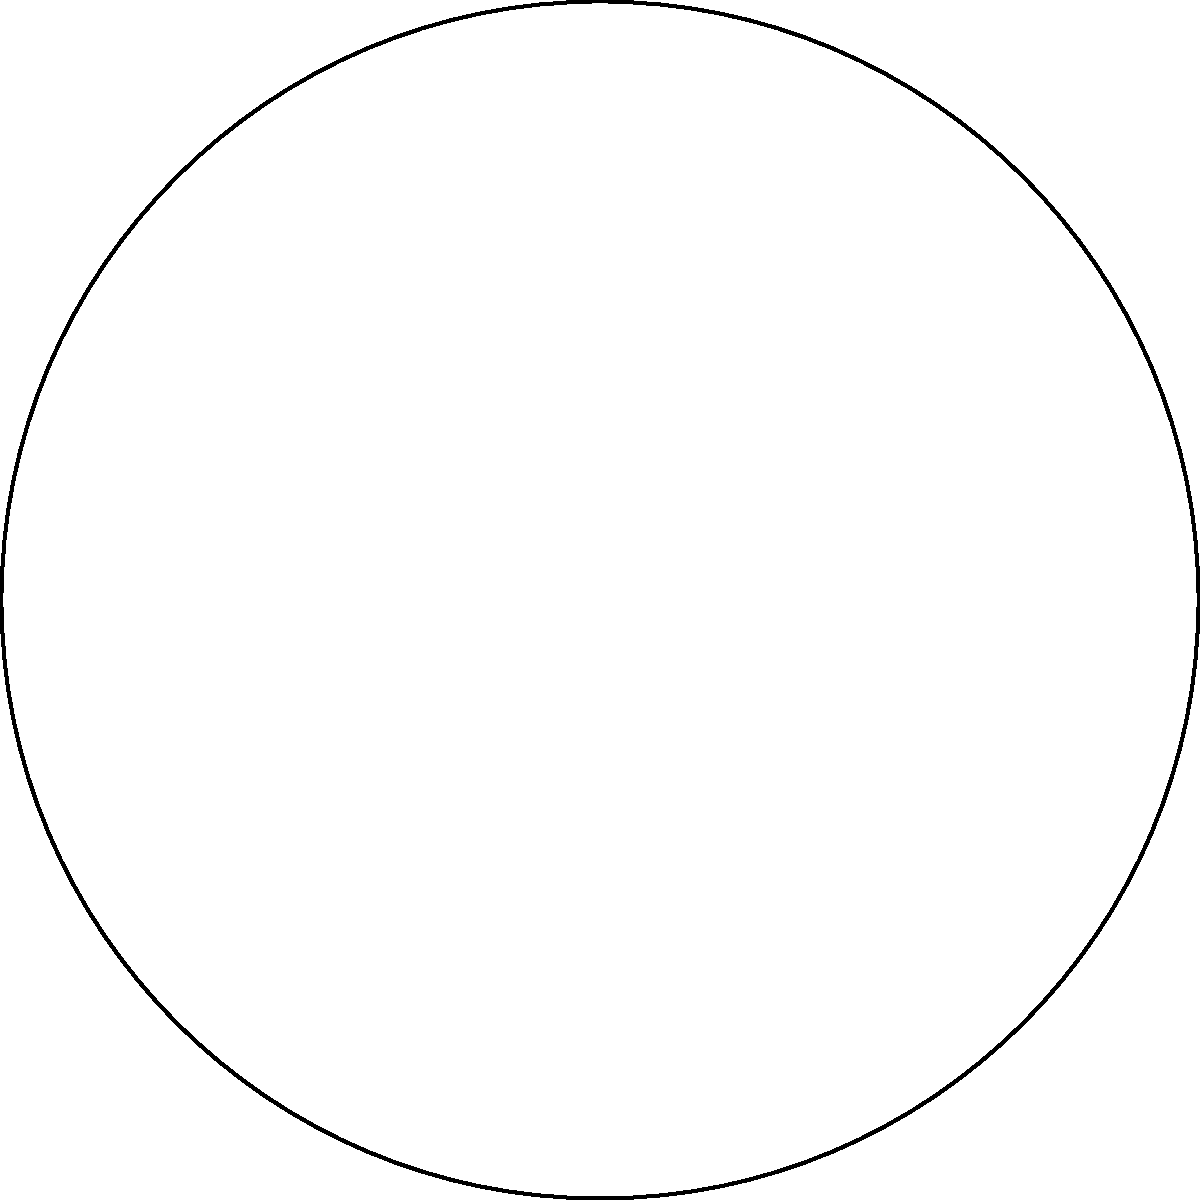In a circular audiobook library, a special section is allocated for tranquil poetry readings. This section forms a sector with a central angle of 135°. If the total area of the circular library is 144π square meters, what is the area of the poetry section? Let's approach this step-by-step:

1) First, recall the formula for the area of a circular sector:
   $A_{sector} = \frac{\theta}{360°} \cdot \pi r^2$
   Where $\theta$ is the central angle in degrees and $r$ is the radius of the circle.

2) We're given that the total area of the circle is 144π square meters. Let's use this to find the radius:
   $A_{circle} = \pi r^2 = 144\pi$
   $r^2 = 144$
   $r = 12$ meters

3) Now we know the radius and the central angle. Let's substitute these into our sector area formula:
   $A_{sector} = \frac{135°}{360°} \cdot \pi (12)^2$

4) Simplify:
   $A_{sector} = \frac{3}{8} \cdot \pi \cdot 144$
   $A_{sector} = 54\pi$ square meters

Therefore, the area of the poetry section is 54π square meters.
Answer: 54π square meters 